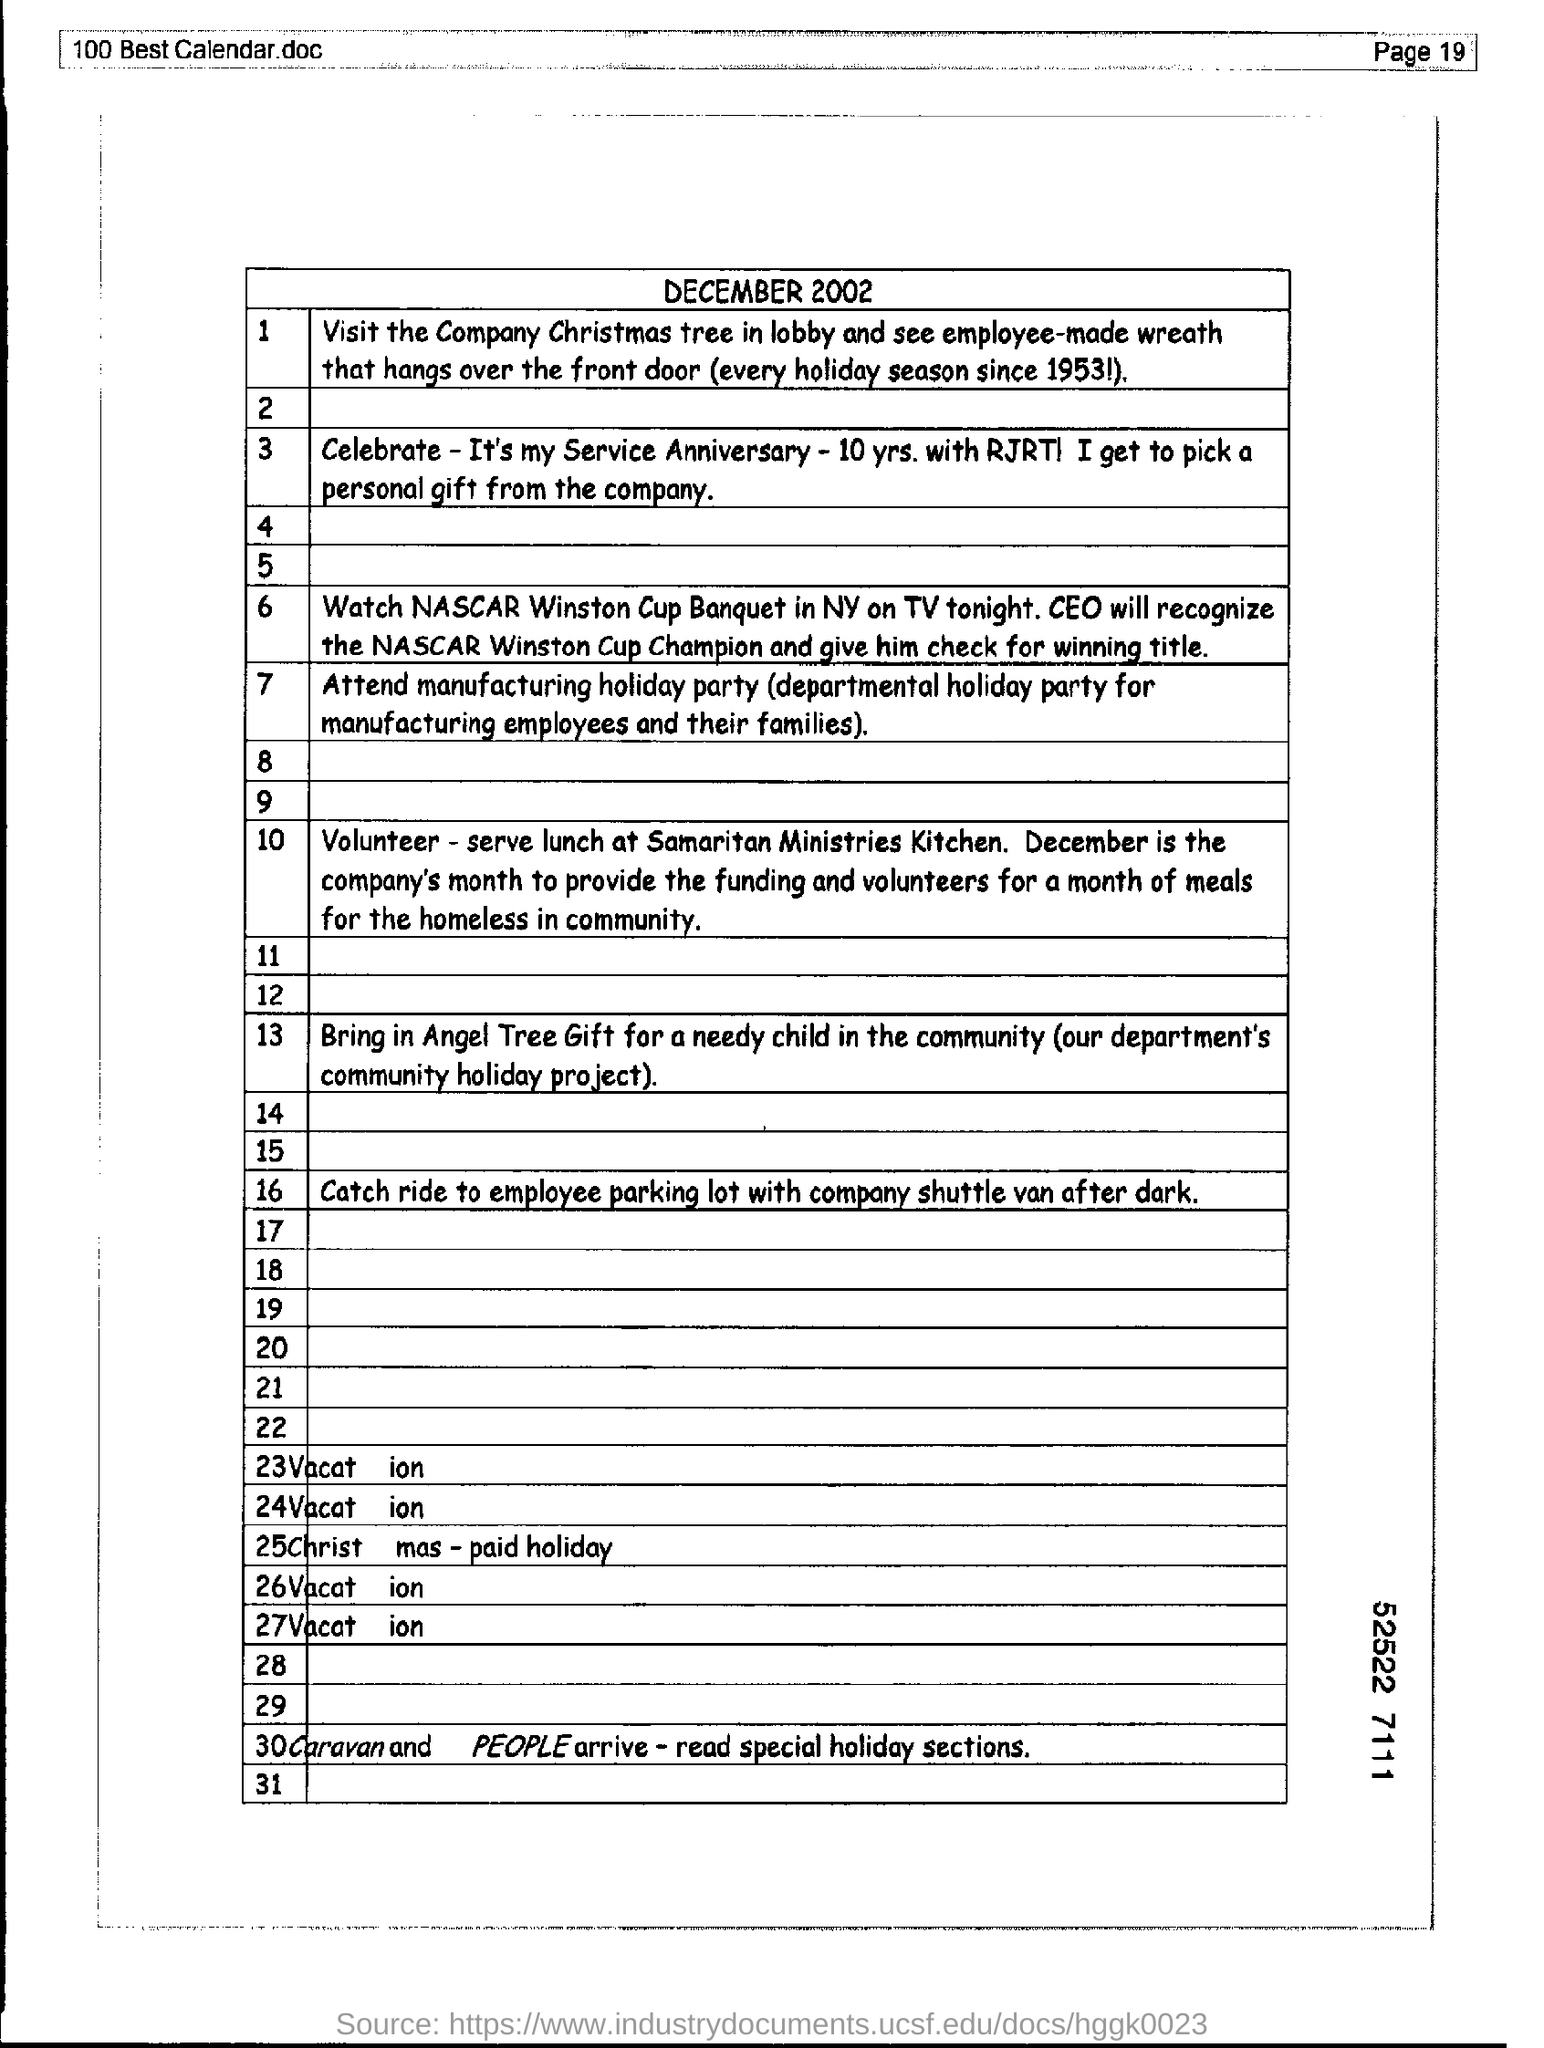Outline some significant characteristics in this image. Please include the page number at the top right corner of the page as shown on page 19. 